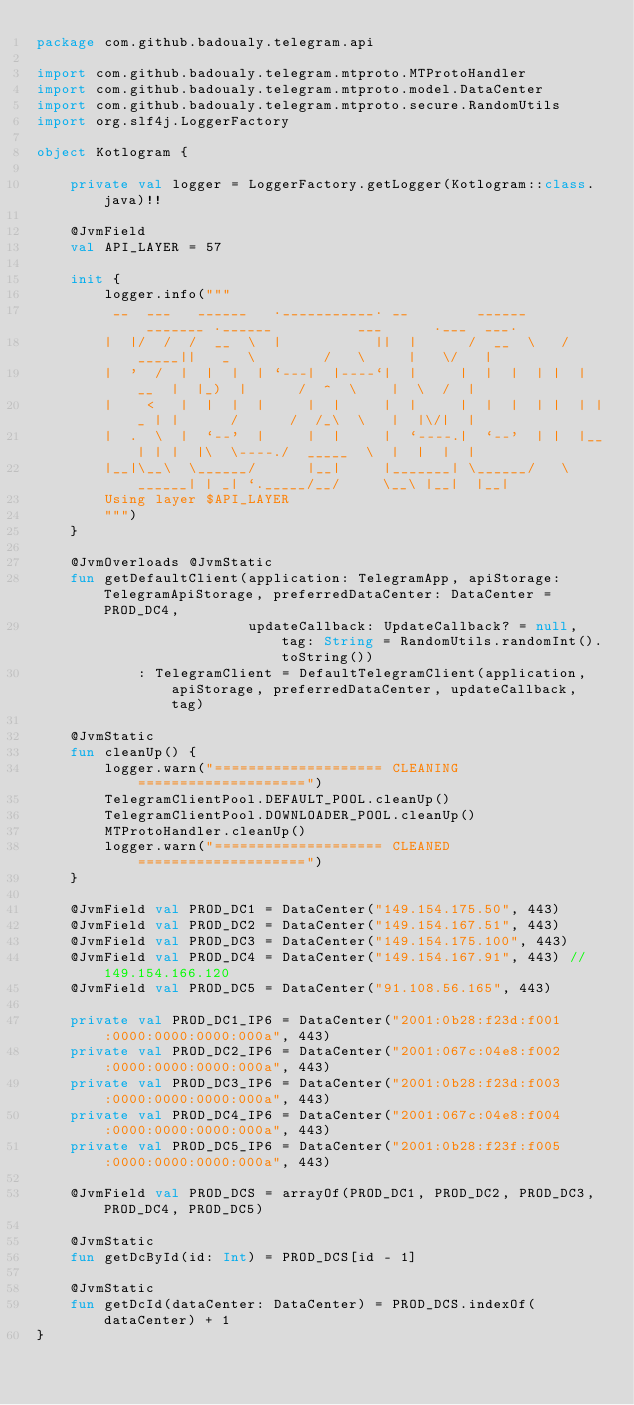<code> <loc_0><loc_0><loc_500><loc_500><_Kotlin_>package com.github.badoualy.telegram.api

import com.github.badoualy.telegram.mtproto.MTProtoHandler
import com.github.badoualy.telegram.mtproto.model.DataCenter
import com.github.badoualy.telegram.mtproto.secure.RandomUtils
import org.slf4j.LoggerFactory

object Kotlogram {

    private val logger = LoggerFactory.getLogger(Kotlogram::class.java)!!

    @JvmField
    val API_LAYER = 57

    init {
        logger.info("""
         __  ___   ______   .___________. __        ______     _______ .______          ___      .___  ___.
        |  |/  /  /  __  \  |           ||  |      /  __  \   /  _____||   _  \        /   \     |   \/   |
        |  '  /  |  |  |  | `---|  |----`|  |     |  |  |  | |  |  __  |  |_)  |      /  ^  \    |  \  /  |
        |    <   |  |  |  |     |  |     |  |     |  |  |  | |  | |_ | |      /      /  /_\  \   |  |\/|  |
        |  .  \  |  `--'  |     |  |     |  `----.|  `--'  | |  |__| | |  |\  \----./  _____  \  |  |  |  |
        |__|\__\  \______/      |__|     |_______| \______/   \______| | _| `._____/__/     \__\ |__|  |__|
        Using layer $API_LAYER
        """)
    }

    @JvmOverloads @JvmStatic
    fun getDefaultClient(application: TelegramApp, apiStorage: TelegramApiStorage, preferredDataCenter: DataCenter = PROD_DC4,
                         updateCallback: UpdateCallback? = null, tag: String = RandomUtils.randomInt().toString())
            : TelegramClient = DefaultTelegramClient(application, apiStorage, preferredDataCenter, updateCallback, tag)

    @JvmStatic
    fun cleanUp() {
        logger.warn("==================== CLEANING ====================")
        TelegramClientPool.DEFAULT_POOL.cleanUp()
        TelegramClientPool.DOWNLOADER_POOL.cleanUp()
        MTProtoHandler.cleanUp()
        logger.warn("==================== CLEANED ====================")
    }

    @JvmField val PROD_DC1 = DataCenter("149.154.175.50", 443)
    @JvmField val PROD_DC2 = DataCenter("149.154.167.51", 443)
    @JvmField val PROD_DC3 = DataCenter("149.154.175.100", 443)
    @JvmField val PROD_DC4 = DataCenter("149.154.167.91", 443) // 149.154.166.120
    @JvmField val PROD_DC5 = DataCenter("91.108.56.165", 443)

    private val PROD_DC1_IP6 = DataCenter("2001:0b28:f23d:f001:0000:0000:0000:000a", 443)
    private val PROD_DC2_IP6 = DataCenter("2001:067c:04e8:f002:0000:0000:0000:000a", 443)
    private val PROD_DC3_IP6 = DataCenter("2001:0b28:f23d:f003:0000:0000:0000:000a", 443)
    private val PROD_DC4_IP6 = DataCenter("2001:067c:04e8:f004:0000:0000:0000:000a", 443)
    private val PROD_DC5_IP6 = DataCenter("2001:0b28:f23f:f005:0000:0000:0000:000a", 443)

    @JvmField val PROD_DCS = arrayOf(PROD_DC1, PROD_DC2, PROD_DC3, PROD_DC4, PROD_DC5)

    @JvmStatic
    fun getDcById(id: Int) = PROD_DCS[id - 1]

    @JvmStatic
    fun getDcId(dataCenter: DataCenter) = PROD_DCS.indexOf(dataCenter) + 1
}

</code> 